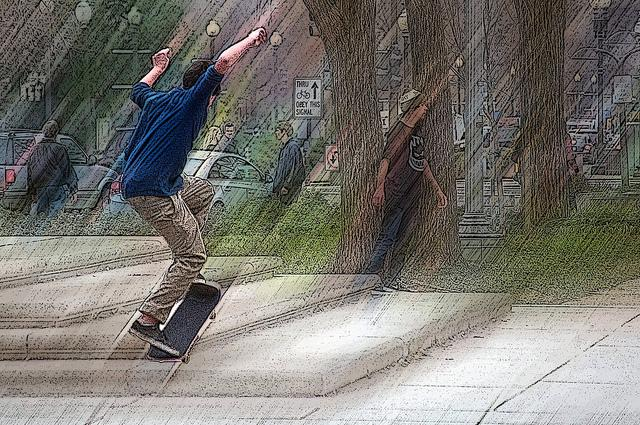World Skate is highest governing body of which game? Please explain your reasoning. skateboarding. A guy is doing skateboarding tricks on stairs. 